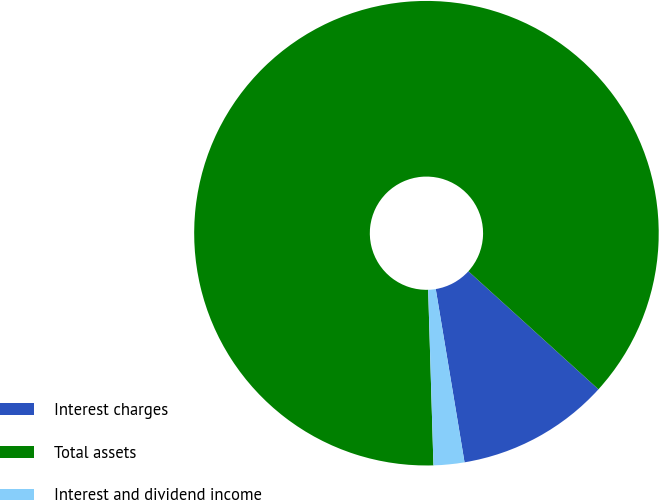Convert chart. <chart><loc_0><loc_0><loc_500><loc_500><pie_chart><fcel>Interest charges<fcel>Total assets<fcel>Interest and dividend income<nl><fcel>10.65%<fcel>87.21%<fcel>2.14%<nl></chart> 